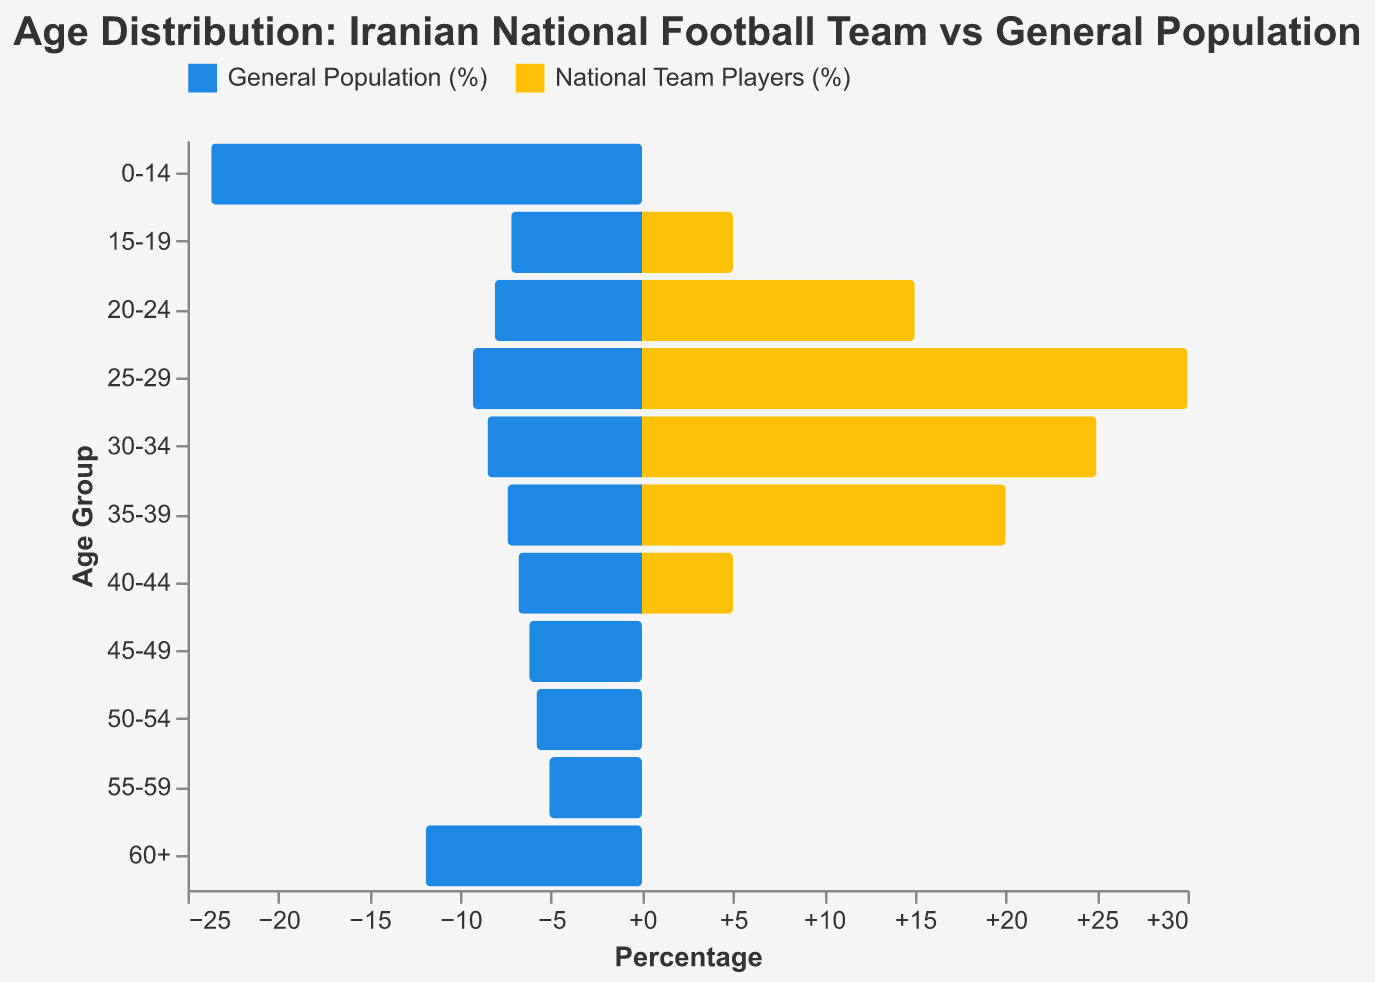What is the title of the figure? The title of the figure is mentioned at the top of the visual. By looking at the top of the chart, we can see that the title is "Age Distribution: Iranian National Football Team vs General Population".
Answer: Age Distribution: Iranian National Football Team vs General Population Which age group has the highest percentage of National Team Players? By looking at the yellow bars which represent National Team Players, we can see that the age group 25-29 has the highest percentage.
Answer: 25-29 How do the age distributions of the general population and national team players compare for the 0-14 age group? The blue bar representing the general population is quite long at 23.7%, whereas the yellow bar for National Team Players is absent, indicating 0%.
Answer: The general population is 23.7%, and National Team Players are 0% What is the difference in the percentage of the 30-34 age group between the general population and national team players? The percentage for the general population in the 30-34 age group is 8.5%, while the percentage for National Team Players is 25%. The difference can be calculated as 25% - 8.5%.
Answer: 16.5% Which age group has the closest percentage value between the general population and national team players? It is necessary to examine the values for both the general population and national team players for each age group. By comparing, we can see that the 15-19 and 40-44 age groups both have similar differences of 2.2% (7.2% vs. 5.0% for the 15-19 and 6.8% vs. 5.0% for the 40-44 groups).
Answer: 15-19 and 40-44 What is the average percentage of national team players for the age groups 20-24, 25-29, and 30-34? Adding the percentages for these groups 15.0% (20-24), 30.0% (25-29), and 25.0% (30-34) gives us 70%. Dividing this sum by 3 (the number of groups) gives an average.
Answer: 23.3% Why might there be no National Team Players in the 0-14 and 60+ age groups? Typically, professional athletes, especially in high-performance sports, do not fall into very young (0-14) or elderly (60+) age categories. These age groups are either too young or have exceeded the peak physical conditions for competitive football.
Answer: Age suitability for professional sports Which category (General Population or National Team Players) has a wider spread of age groups? By looking at the distribution of the bars, the general population has percentages spread across all age groups from 0-14 up to 60+, while the National Team Players are only represented from 15-19 to 40-44.
Answer: General Population What percentage of national team players are in the age group 35-39? The percentage is directly read from the yellow bar corresponding to the age group 35-39 for National Team Players, which is 20%.
Answer: 20% 